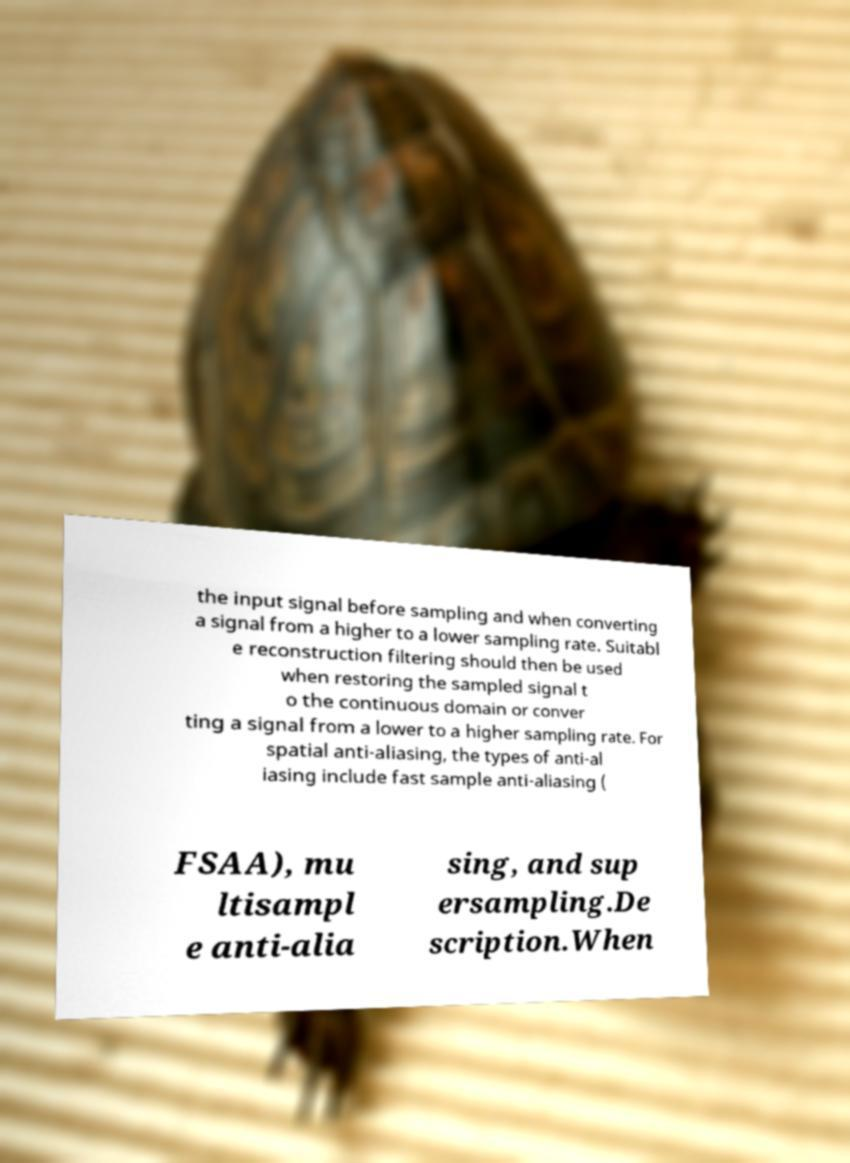There's text embedded in this image that I need extracted. Can you transcribe it verbatim? the input signal before sampling and when converting a signal from a higher to a lower sampling rate. Suitabl e reconstruction filtering should then be used when restoring the sampled signal t o the continuous domain or conver ting a signal from a lower to a higher sampling rate. For spatial anti-aliasing, the types of anti-al iasing include fast sample anti-aliasing ( FSAA), mu ltisampl e anti-alia sing, and sup ersampling.De scription.When 